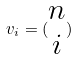<formula> <loc_0><loc_0><loc_500><loc_500>v _ { i } = ( \begin{matrix} n \\ i \end{matrix} )</formula> 